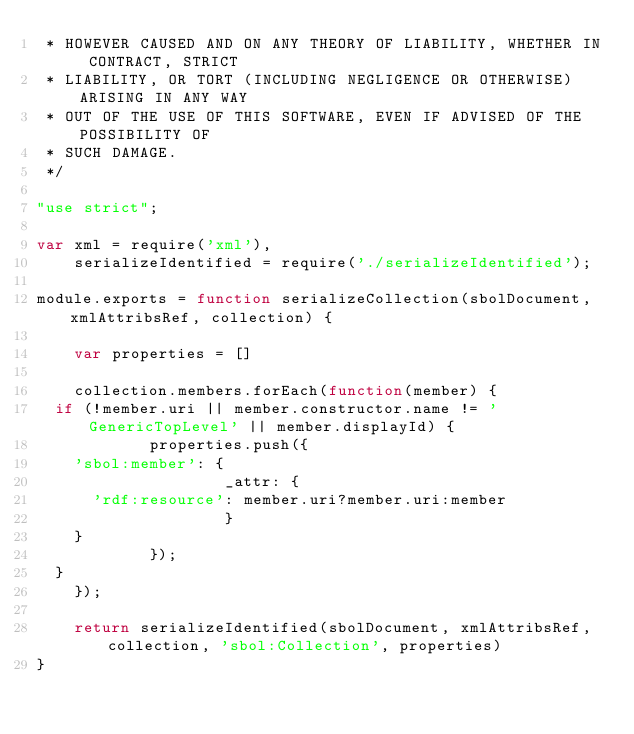Convert code to text. <code><loc_0><loc_0><loc_500><loc_500><_JavaScript_> * HOWEVER CAUSED AND ON ANY THEORY OF LIABILITY, WHETHER IN CONTRACT, STRICT
 * LIABILITY, OR TORT (INCLUDING NEGLIGENCE OR OTHERWISE) ARISING IN ANY WAY
 * OUT OF THE USE OF THIS SOFTWARE, EVEN IF ADVISED OF THE POSSIBILITY OF
 * SUCH DAMAGE.
 */

"use strict";

var xml = require('xml'),
    serializeIdentified = require('./serializeIdentified');

module.exports = function serializeCollection(sbolDocument, xmlAttribsRef, collection) {

    var properties = []

    collection.members.forEach(function(member) {
	if (!member.uri || member.constructor.name != 'GenericTopLevel' || member.displayId) {
            properties.push({
		'sbol:member': {
                    _attr: {
			'rdf:resource': member.uri?member.uri:member
                    }
		}
            });
	}
    });

    return serializeIdentified(sbolDocument, xmlAttribsRef, collection, 'sbol:Collection', properties)
}

</code> 